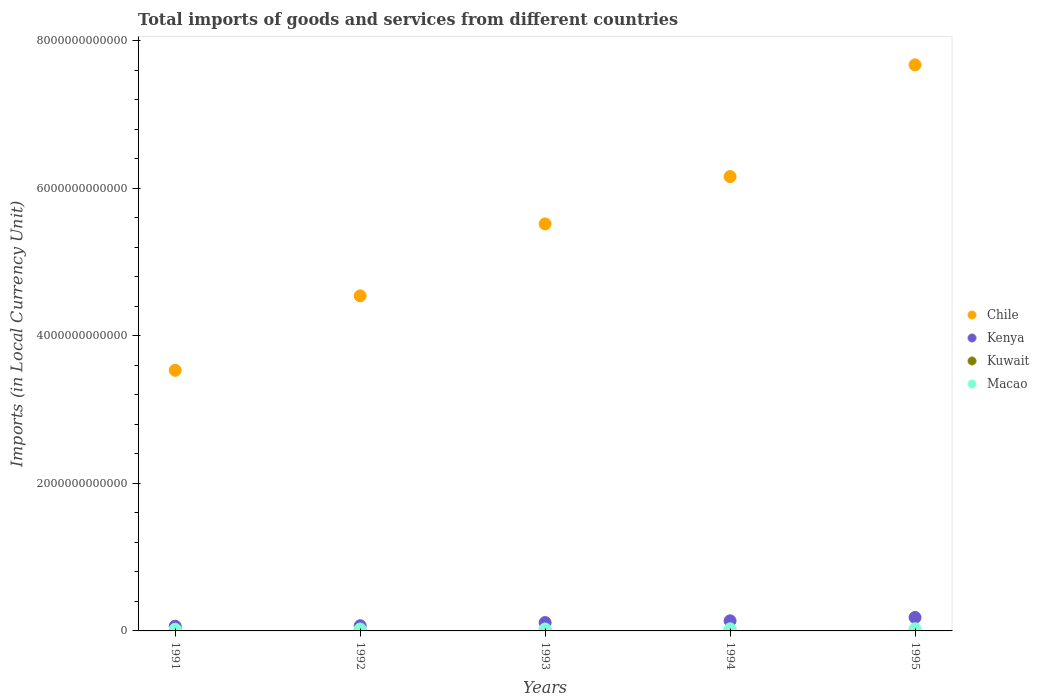How many different coloured dotlines are there?
Your answer should be very brief. 4. Is the number of dotlines equal to the number of legend labels?
Provide a succinct answer. Yes. What is the Amount of goods and services imports in Macao in 1995?
Offer a very short reply. 2.89e+1. Across all years, what is the maximum Amount of goods and services imports in Kuwait?
Your response must be concise. 3.93e+09. Across all years, what is the minimum Amount of goods and services imports in Kenya?
Offer a terse response. 6.40e+1. In which year was the Amount of goods and services imports in Macao maximum?
Give a very brief answer. 1995. In which year was the Amount of goods and services imports in Kenya minimum?
Provide a succinct answer. 1991. What is the total Amount of goods and services imports in Kuwait in the graph?
Your answer should be compact. 1.68e+1. What is the difference between the Amount of goods and services imports in Kuwait in 1993 and that in 1994?
Offer a terse response. 7.80e+07. What is the difference between the Amount of goods and services imports in Chile in 1992 and the Amount of goods and services imports in Kenya in 1994?
Your response must be concise. 4.40e+12. What is the average Amount of goods and services imports in Chile per year?
Provide a succinct answer. 5.48e+12. In the year 1992, what is the difference between the Amount of goods and services imports in Macao and Amount of goods and services imports in Kuwait?
Provide a short and direct response. 2.23e+1. In how many years, is the Amount of goods and services imports in Chile greater than 2800000000000 LCU?
Your answer should be compact. 5. What is the ratio of the Amount of goods and services imports in Chile in 1992 to that in 1995?
Provide a succinct answer. 0.59. Is the Amount of goods and services imports in Kenya in 1994 less than that in 1995?
Ensure brevity in your answer.  Yes. Is the difference between the Amount of goods and services imports in Macao in 1991 and 1993 greater than the difference between the Amount of goods and services imports in Kuwait in 1991 and 1993?
Offer a very short reply. No. What is the difference between the highest and the second highest Amount of goods and services imports in Kenya?
Ensure brevity in your answer.  4.50e+1. What is the difference between the highest and the lowest Amount of goods and services imports in Macao?
Your answer should be compact. 5.71e+09. In how many years, is the Amount of goods and services imports in Chile greater than the average Amount of goods and services imports in Chile taken over all years?
Offer a terse response. 3. Is the sum of the Amount of goods and services imports in Kuwait in 1993 and 1994 greater than the maximum Amount of goods and services imports in Macao across all years?
Make the answer very short. No. Is it the case that in every year, the sum of the Amount of goods and services imports in Kenya and Amount of goods and services imports in Chile  is greater than the sum of Amount of goods and services imports in Kuwait and Amount of goods and services imports in Macao?
Give a very brief answer. Yes. Is it the case that in every year, the sum of the Amount of goods and services imports in Kuwait and Amount of goods and services imports in Chile  is greater than the Amount of goods and services imports in Kenya?
Offer a terse response. Yes. Does the Amount of goods and services imports in Macao monotonically increase over the years?
Provide a succinct answer. Yes. Is the Amount of goods and services imports in Kenya strictly less than the Amount of goods and services imports in Macao over the years?
Offer a terse response. No. What is the difference between two consecutive major ticks on the Y-axis?
Provide a short and direct response. 2.00e+12. Are the values on the major ticks of Y-axis written in scientific E-notation?
Provide a succinct answer. No. Does the graph contain any zero values?
Give a very brief answer. No. Where does the legend appear in the graph?
Offer a very short reply. Center right. How many legend labels are there?
Offer a terse response. 4. What is the title of the graph?
Offer a terse response. Total imports of goods and services from different countries. Does "Guyana" appear as one of the legend labels in the graph?
Give a very brief answer. No. What is the label or title of the Y-axis?
Provide a succinct answer. Imports (in Local Currency Unit). What is the Imports (in Local Currency Unit) in Chile in 1991?
Make the answer very short. 3.53e+12. What is the Imports (in Local Currency Unit) in Kenya in 1991?
Keep it short and to the point. 6.40e+1. What is the Imports (in Local Currency Unit) in Kuwait in 1991?
Your response must be concise. 3.93e+09. What is the Imports (in Local Currency Unit) in Macao in 1991?
Make the answer very short. 2.32e+1. What is the Imports (in Local Currency Unit) of Chile in 1992?
Make the answer very short. 4.54e+12. What is the Imports (in Local Currency Unit) of Kenya in 1992?
Make the answer very short. 7.05e+1. What is the Imports (in Local Currency Unit) of Kuwait in 1992?
Make the answer very short. 3.16e+09. What is the Imports (in Local Currency Unit) of Macao in 1992?
Provide a short and direct response. 2.55e+1. What is the Imports (in Local Currency Unit) in Chile in 1993?
Offer a very short reply. 5.52e+12. What is the Imports (in Local Currency Unit) in Kenya in 1993?
Provide a short and direct response. 1.13e+11. What is the Imports (in Local Currency Unit) of Kuwait in 1993?
Provide a succinct answer. 3.20e+09. What is the Imports (in Local Currency Unit) in Macao in 1993?
Provide a succinct answer. 2.64e+1. What is the Imports (in Local Currency Unit) of Chile in 1994?
Your response must be concise. 6.16e+12. What is the Imports (in Local Currency Unit) in Kenya in 1994?
Provide a succinct answer. 1.37e+11. What is the Imports (in Local Currency Unit) of Kuwait in 1994?
Offer a very short reply. 3.12e+09. What is the Imports (in Local Currency Unit) in Macao in 1994?
Your response must be concise. 2.86e+1. What is the Imports (in Local Currency Unit) in Chile in 1995?
Provide a short and direct response. 7.67e+12. What is the Imports (in Local Currency Unit) of Kenya in 1995?
Keep it short and to the point. 1.82e+11. What is the Imports (in Local Currency Unit) of Kuwait in 1995?
Offer a terse response. 3.40e+09. What is the Imports (in Local Currency Unit) of Macao in 1995?
Provide a succinct answer. 2.89e+1. Across all years, what is the maximum Imports (in Local Currency Unit) in Chile?
Offer a terse response. 7.67e+12. Across all years, what is the maximum Imports (in Local Currency Unit) of Kenya?
Offer a terse response. 1.82e+11. Across all years, what is the maximum Imports (in Local Currency Unit) in Kuwait?
Provide a succinct answer. 3.93e+09. Across all years, what is the maximum Imports (in Local Currency Unit) of Macao?
Make the answer very short. 2.89e+1. Across all years, what is the minimum Imports (in Local Currency Unit) of Chile?
Make the answer very short. 3.53e+12. Across all years, what is the minimum Imports (in Local Currency Unit) of Kenya?
Keep it short and to the point. 6.40e+1. Across all years, what is the minimum Imports (in Local Currency Unit) of Kuwait?
Provide a succinct answer. 3.12e+09. Across all years, what is the minimum Imports (in Local Currency Unit) in Macao?
Offer a very short reply. 2.32e+1. What is the total Imports (in Local Currency Unit) of Chile in the graph?
Provide a succinct answer. 2.74e+13. What is the total Imports (in Local Currency Unit) in Kenya in the graph?
Provide a short and direct response. 5.67e+11. What is the total Imports (in Local Currency Unit) in Kuwait in the graph?
Your answer should be very brief. 1.68e+1. What is the total Imports (in Local Currency Unit) of Macao in the graph?
Provide a short and direct response. 1.32e+11. What is the difference between the Imports (in Local Currency Unit) in Chile in 1991 and that in 1992?
Make the answer very short. -1.01e+12. What is the difference between the Imports (in Local Currency Unit) in Kenya in 1991 and that in 1992?
Your answer should be compact. -6.50e+09. What is the difference between the Imports (in Local Currency Unit) of Kuwait in 1991 and that in 1992?
Your answer should be very brief. 7.76e+08. What is the difference between the Imports (in Local Currency Unit) of Macao in 1991 and that in 1992?
Your answer should be compact. -2.31e+09. What is the difference between the Imports (in Local Currency Unit) in Chile in 1991 and that in 1993?
Your response must be concise. -1.98e+12. What is the difference between the Imports (in Local Currency Unit) of Kenya in 1991 and that in 1993?
Keep it short and to the point. -4.92e+1. What is the difference between the Imports (in Local Currency Unit) of Kuwait in 1991 and that in 1993?
Offer a very short reply. 7.33e+08. What is the difference between the Imports (in Local Currency Unit) of Macao in 1991 and that in 1993?
Make the answer very short. -3.22e+09. What is the difference between the Imports (in Local Currency Unit) of Chile in 1991 and that in 1994?
Your response must be concise. -2.63e+12. What is the difference between the Imports (in Local Currency Unit) of Kenya in 1991 and that in 1994?
Your answer should be very brief. -7.31e+1. What is the difference between the Imports (in Local Currency Unit) of Kuwait in 1991 and that in 1994?
Provide a succinct answer. 8.11e+08. What is the difference between the Imports (in Local Currency Unit) in Macao in 1991 and that in 1994?
Provide a succinct answer. -5.41e+09. What is the difference between the Imports (in Local Currency Unit) in Chile in 1991 and that in 1995?
Ensure brevity in your answer.  -4.14e+12. What is the difference between the Imports (in Local Currency Unit) of Kenya in 1991 and that in 1995?
Offer a very short reply. -1.18e+11. What is the difference between the Imports (in Local Currency Unit) of Kuwait in 1991 and that in 1995?
Make the answer very short. 5.30e+08. What is the difference between the Imports (in Local Currency Unit) of Macao in 1991 and that in 1995?
Give a very brief answer. -5.71e+09. What is the difference between the Imports (in Local Currency Unit) in Chile in 1992 and that in 1993?
Ensure brevity in your answer.  -9.75e+11. What is the difference between the Imports (in Local Currency Unit) of Kenya in 1992 and that in 1993?
Offer a very short reply. -4.27e+1. What is the difference between the Imports (in Local Currency Unit) of Kuwait in 1992 and that in 1993?
Your answer should be very brief. -4.30e+07. What is the difference between the Imports (in Local Currency Unit) in Macao in 1992 and that in 1993?
Offer a very short reply. -9.16e+08. What is the difference between the Imports (in Local Currency Unit) of Chile in 1992 and that in 1994?
Your response must be concise. -1.62e+12. What is the difference between the Imports (in Local Currency Unit) in Kenya in 1992 and that in 1994?
Offer a terse response. -6.66e+1. What is the difference between the Imports (in Local Currency Unit) in Kuwait in 1992 and that in 1994?
Ensure brevity in your answer.  3.50e+07. What is the difference between the Imports (in Local Currency Unit) of Macao in 1992 and that in 1994?
Your answer should be compact. -3.10e+09. What is the difference between the Imports (in Local Currency Unit) of Chile in 1992 and that in 1995?
Keep it short and to the point. -3.13e+12. What is the difference between the Imports (in Local Currency Unit) of Kenya in 1992 and that in 1995?
Offer a terse response. -1.12e+11. What is the difference between the Imports (in Local Currency Unit) in Kuwait in 1992 and that in 1995?
Your response must be concise. -2.46e+08. What is the difference between the Imports (in Local Currency Unit) in Macao in 1992 and that in 1995?
Your answer should be very brief. -3.40e+09. What is the difference between the Imports (in Local Currency Unit) in Chile in 1993 and that in 1994?
Offer a terse response. -6.42e+11. What is the difference between the Imports (in Local Currency Unit) in Kenya in 1993 and that in 1994?
Offer a very short reply. -2.39e+1. What is the difference between the Imports (in Local Currency Unit) in Kuwait in 1993 and that in 1994?
Your response must be concise. 7.80e+07. What is the difference between the Imports (in Local Currency Unit) in Macao in 1993 and that in 1994?
Your answer should be compact. -2.18e+09. What is the difference between the Imports (in Local Currency Unit) of Chile in 1993 and that in 1995?
Offer a very short reply. -2.16e+12. What is the difference between the Imports (in Local Currency Unit) in Kenya in 1993 and that in 1995?
Offer a terse response. -6.89e+1. What is the difference between the Imports (in Local Currency Unit) in Kuwait in 1993 and that in 1995?
Keep it short and to the point. -2.03e+08. What is the difference between the Imports (in Local Currency Unit) of Macao in 1993 and that in 1995?
Provide a short and direct response. -2.48e+09. What is the difference between the Imports (in Local Currency Unit) in Chile in 1994 and that in 1995?
Offer a terse response. -1.51e+12. What is the difference between the Imports (in Local Currency Unit) in Kenya in 1994 and that in 1995?
Keep it short and to the point. -4.50e+1. What is the difference between the Imports (in Local Currency Unit) of Kuwait in 1994 and that in 1995?
Your answer should be very brief. -2.81e+08. What is the difference between the Imports (in Local Currency Unit) in Macao in 1994 and that in 1995?
Provide a short and direct response. -2.98e+08. What is the difference between the Imports (in Local Currency Unit) of Chile in 1991 and the Imports (in Local Currency Unit) of Kenya in 1992?
Your response must be concise. 3.46e+12. What is the difference between the Imports (in Local Currency Unit) of Chile in 1991 and the Imports (in Local Currency Unit) of Kuwait in 1992?
Your answer should be very brief. 3.53e+12. What is the difference between the Imports (in Local Currency Unit) in Chile in 1991 and the Imports (in Local Currency Unit) in Macao in 1992?
Offer a terse response. 3.51e+12. What is the difference between the Imports (in Local Currency Unit) of Kenya in 1991 and the Imports (in Local Currency Unit) of Kuwait in 1992?
Make the answer very short. 6.09e+1. What is the difference between the Imports (in Local Currency Unit) of Kenya in 1991 and the Imports (in Local Currency Unit) of Macao in 1992?
Your answer should be compact. 3.86e+1. What is the difference between the Imports (in Local Currency Unit) of Kuwait in 1991 and the Imports (in Local Currency Unit) of Macao in 1992?
Provide a short and direct response. -2.15e+1. What is the difference between the Imports (in Local Currency Unit) of Chile in 1991 and the Imports (in Local Currency Unit) of Kenya in 1993?
Offer a very short reply. 3.42e+12. What is the difference between the Imports (in Local Currency Unit) in Chile in 1991 and the Imports (in Local Currency Unit) in Kuwait in 1993?
Your response must be concise. 3.53e+12. What is the difference between the Imports (in Local Currency Unit) of Chile in 1991 and the Imports (in Local Currency Unit) of Macao in 1993?
Give a very brief answer. 3.51e+12. What is the difference between the Imports (in Local Currency Unit) in Kenya in 1991 and the Imports (in Local Currency Unit) in Kuwait in 1993?
Keep it short and to the point. 6.08e+1. What is the difference between the Imports (in Local Currency Unit) of Kenya in 1991 and the Imports (in Local Currency Unit) of Macao in 1993?
Your answer should be compact. 3.77e+1. What is the difference between the Imports (in Local Currency Unit) of Kuwait in 1991 and the Imports (in Local Currency Unit) of Macao in 1993?
Provide a short and direct response. -2.24e+1. What is the difference between the Imports (in Local Currency Unit) of Chile in 1991 and the Imports (in Local Currency Unit) of Kenya in 1994?
Ensure brevity in your answer.  3.40e+12. What is the difference between the Imports (in Local Currency Unit) in Chile in 1991 and the Imports (in Local Currency Unit) in Kuwait in 1994?
Provide a short and direct response. 3.53e+12. What is the difference between the Imports (in Local Currency Unit) of Chile in 1991 and the Imports (in Local Currency Unit) of Macao in 1994?
Keep it short and to the point. 3.50e+12. What is the difference between the Imports (in Local Currency Unit) in Kenya in 1991 and the Imports (in Local Currency Unit) in Kuwait in 1994?
Offer a terse response. 6.09e+1. What is the difference between the Imports (in Local Currency Unit) of Kenya in 1991 and the Imports (in Local Currency Unit) of Macao in 1994?
Offer a terse response. 3.55e+1. What is the difference between the Imports (in Local Currency Unit) of Kuwait in 1991 and the Imports (in Local Currency Unit) of Macao in 1994?
Make the answer very short. -2.46e+1. What is the difference between the Imports (in Local Currency Unit) in Chile in 1991 and the Imports (in Local Currency Unit) in Kenya in 1995?
Provide a succinct answer. 3.35e+12. What is the difference between the Imports (in Local Currency Unit) in Chile in 1991 and the Imports (in Local Currency Unit) in Kuwait in 1995?
Provide a succinct answer. 3.53e+12. What is the difference between the Imports (in Local Currency Unit) in Chile in 1991 and the Imports (in Local Currency Unit) in Macao in 1995?
Offer a terse response. 3.50e+12. What is the difference between the Imports (in Local Currency Unit) in Kenya in 1991 and the Imports (in Local Currency Unit) in Kuwait in 1995?
Offer a very short reply. 6.06e+1. What is the difference between the Imports (in Local Currency Unit) of Kenya in 1991 and the Imports (in Local Currency Unit) of Macao in 1995?
Give a very brief answer. 3.52e+1. What is the difference between the Imports (in Local Currency Unit) in Kuwait in 1991 and the Imports (in Local Currency Unit) in Macao in 1995?
Offer a very short reply. -2.49e+1. What is the difference between the Imports (in Local Currency Unit) of Chile in 1992 and the Imports (in Local Currency Unit) of Kenya in 1993?
Keep it short and to the point. 4.43e+12. What is the difference between the Imports (in Local Currency Unit) of Chile in 1992 and the Imports (in Local Currency Unit) of Kuwait in 1993?
Make the answer very short. 4.54e+12. What is the difference between the Imports (in Local Currency Unit) of Chile in 1992 and the Imports (in Local Currency Unit) of Macao in 1993?
Make the answer very short. 4.52e+12. What is the difference between the Imports (in Local Currency Unit) of Kenya in 1992 and the Imports (in Local Currency Unit) of Kuwait in 1993?
Your answer should be compact. 6.73e+1. What is the difference between the Imports (in Local Currency Unit) of Kenya in 1992 and the Imports (in Local Currency Unit) of Macao in 1993?
Make the answer very short. 4.42e+1. What is the difference between the Imports (in Local Currency Unit) of Kuwait in 1992 and the Imports (in Local Currency Unit) of Macao in 1993?
Give a very brief answer. -2.32e+1. What is the difference between the Imports (in Local Currency Unit) in Chile in 1992 and the Imports (in Local Currency Unit) in Kenya in 1994?
Your answer should be very brief. 4.40e+12. What is the difference between the Imports (in Local Currency Unit) of Chile in 1992 and the Imports (in Local Currency Unit) of Kuwait in 1994?
Offer a terse response. 4.54e+12. What is the difference between the Imports (in Local Currency Unit) of Chile in 1992 and the Imports (in Local Currency Unit) of Macao in 1994?
Your answer should be compact. 4.51e+12. What is the difference between the Imports (in Local Currency Unit) in Kenya in 1992 and the Imports (in Local Currency Unit) in Kuwait in 1994?
Provide a succinct answer. 6.74e+1. What is the difference between the Imports (in Local Currency Unit) of Kenya in 1992 and the Imports (in Local Currency Unit) of Macao in 1994?
Give a very brief answer. 4.20e+1. What is the difference between the Imports (in Local Currency Unit) of Kuwait in 1992 and the Imports (in Local Currency Unit) of Macao in 1994?
Your response must be concise. -2.54e+1. What is the difference between the Imports (in Local Currency Unit) in Chile in 1992 and the Imports (in Local Currency Unit) in Kenya in 1995?
Provide a short and direct response. 4.36e+12. What is the difference between the Imports (in Local Currency Unit) in Chile in 1992 and the Imports (in Local Currency Unit) in Kuwait in 1995?
Offer a very short reply. 4.54e+12. What is the difference between the Imports (in Local Currency Unit) of Chile in 1992 and the Imports (in Local Currency Unit) of Macao in 1995?
Provide a succinct answer. 4.51e+12. What is the difference between the Imports (in Local Currency Unit) of Kenya in 1992 and the Imports (in Local Currency Unit) of Kuwait in 1995?
Provide a short and direct response. 6.71e+1. What is the difference between the Imports (in Local Currency Unit) in Kenya in 1992 and the Imports (in Local Currency Unit) in Macao in 1995?
Offer a terse response. 4.17e+1. What is the difference between the Imports (in Local Currency Unit) in Kuwait in 1992 and the Imports (in Local Currency Unit) in Macao in 1995?
Provide a succinct answer. -2.57e+1. What is the difference between the Imports (in Local Currency Unit) of Chile in 1993 and the Imports (in Local Currency Unit) of Kenya in 1994?
Your response must be concise. 5.38e+12. What is the difference between the Imports (in Local Currency Unit) in Chile in 1993 and the Imports (in Local Currency Unit) in Kuwait in 1994?
Ensure brevity in your answer.  5.51e+12. What is the difference between the Imports (in Local Currency Unit) of Chile in 1993 and the Imports (in Local Currency Unit) of Macao in 1994?
Make the answer very short. 5.49e+12. What is the difference between the Imports (in Local Currency Unit) of Kenya in 1993 and the Imports (in Local Currency Unit) of Kuwait in 1994?
Offer a very short reply. 1.10e+11. What is the difference between the Imports (in Local Currency Unit) in Kenya in 1993 and the Imports (in Local Currency Unit) in Macao in 1994?
Your response must be concise. 8.47e+1. What is the difference between the Imports (in Local Currency Unit) of Kuwait in 1993 and the Imports (in Local Currency Unit) of Macao in 1994?
Your answer should be compact. -2.54e+1. What is the difference between the Imports (in Local Currency Unit) of Chile in 1993 and the Imports (in Local Currency Unit) of Kenya in 1995?
Offer a terse response. 5.33e+12. What is the difference between the Imports (in Local Currency Unit) of Chile in 1993 and the Imports (in Local Currency Unit) of Kuwait in 1995?
Provide a succinct answer. 5.51e+12. What is the difference between the Imports (in Local Currency Unit) of Chile in 1993 and the Imports (in Local Currency Unit) of Macao in 1995?
Make the answer very short. 5.49e+12. What is the difference between the Imports (in Local Currency Unit) of Kenya in 1993 and the Imports (in Local Currency Unit) of Kuwait in 1995?
Your answer should be compact. 1.10e+11. What is the difference between the Imports (in Local Currency Unit) in Kenya in 1993 and the Imports (in Local Currency Unit) in Macao in 1995?
Provide a succinct answer. 8.44e+1. What is the difference between the Imports (in Local Currency Unit) of Kuwait in 1993 and the Imports (in Local Currency Unit) of Macao in 1995?
Keep it short and to the point. -2.57e+1. What is the difference between the Imports (in Local Currency Unit) of Chile in 1994 and the Imports (in Local Currency Unit) of Kenya in 1995?
Give a very brief answer. 5.98e+12. What is the difference between the Imports (in Local Currency Unit) in Chile in 1994 and the Imports (in Local Currency Unit) in Kuwait in 1995?
Your answer should be compact. 6.16e+12. What is the difference between the Imports (in Local Currency Unit) of Chile in 1994 and the Imports (in Local Currency Unit) of Macao in 1995?
Make the answer very short. 6.13e+12. What is the difference between the Imports (in Local Currency Unit) of Kenya in 1994 and the Imports (in Local Currency Unit) of Kuwait in 1995?
Provide a short and direct response. 1.34e+11. What is the difference between the Imports (in Local Currency Unit) in Kenya in 1994 and the Imports (in Local Currency Unit) in Macao in 1995?
Ensure brevity in your answer.  1.08e+11. What is the difference between the Imports (in Local Currency Unit) of Kuwait in 1994 and the Imports (in Local Currency Unit) of Macao in 1995?
Offer a terse response. -2.57e+1. What is the average Imports (in Local Currency Unit) in Chile per year?
Make the answer very short. 5.48e+12. What is the average Imports (in Local Currency Unit) in Kenya per year?
Provide a short and direct response. 1.13e+11. What is the average Imports (in Local Currency Unit) in Kuwait per year?
Your answer should be very brief. 3.36e+09. What is the average Imports (in Local Currency Unit) of Macao per year?
Provide a short and direct response. 2.65e+1. In the year 1991, what is the difference between the Imports (in Local Currency Unit) of Chile and Imports (in Local Currency Unit) of Kenya?
Make the answer very short. 3.47e+12. In the year 1991, what is the difference between the Imports (in Local Currency Unit) of Chile and Imports (in Local Currency Unit) of Kuwait?
Your response must be concise. 3.53e+12. In the year 1991, what is the difference between the Imports (in Local Currency Unit) of Chile and Imports (in Local Currency Unit) of Macao?
Provide a short and direct response. 3.51e+12. In the year 1991, what is the difference between the Imports (in Local Currency Unit) of Kenya and Imports (in Local Currency Unit) of Kuwait?
Your response must be concise. 6.01e+1. In the year 1991, what is the difference between the Imports (in Local Currency Unit) in Kenya and Imports (in Local Currency Unit) in Macao?
Your answer should be very brief. 4.09e+1. In the year 1991, what is the difference between the Imports (in Local Currency Unit) in Kuwait and Imports (in Local Currency Unit) in Macao?
Give a very brief answer. -1.92e+1. In the year 1992, what is the difference between the Imports (in Local Currency Unit) of Chile and Imports (in Local Currency Unit) of Kenya?
Provide a short and direct response. 4.47e+12. In the year 1992, what is the difference between the Imports (in Local Currency Unit) of Chile and Imports (in Local Currency Unit) of Kuwait?
Give a very brief answer. 4.54e+12. In the year 1992, what is the difference between the Imports (in Local Currency Unit) in Chile and Imports (in Local Currency Unit) in Macao?
Make the answer very short. 4.52e+12. In the year 1992, what is the difference between the Imports (in Local Currency Unit) of Kenya and Imports (in Local Currency Unit) of Kuwait?
Offer a terse response. 6.74e+1. In the year 1992, what is the difference between the Imports (in Local Currency Unit) of Kenya and Imports (in Local Currency Unit) of Macao?
Provide a short and direct response. 4.51e+1. In the year 1992, what is the difference between the Imports (in Local Currency Unit) of Kuwait and Imports (in Local Currency Unit) of Macao?
Provide a short and direct response. -2.23e+1. In the year 1993, what is the difference between the Imports (in Local Currency Unit) of Chile and Imports (in Local Currency Unit) of Kenya?
Give a very brief answer. 5.40e+12. In the year 1993, what is the difference between the Imports (in Local Currency Unit) of Chile and Imports (in Local Currency Unit) of Kuwait?
Keep it short and to the point. 5.51e+12. In the year 1993, what is the difference between the Imports (in Local Currency Unit) in Chile and Imports (in Local Currency Unit) in Macao?
Provide a succinct answer. 5.49e+12. In the year 1993, what is the difference between the Imports (in Local Currency Unit) of Kenya and Imports (in Local Currency Unit) of Kuwait?
Provide a succinct answer. 1.10e+11. In the year 1993, what is the difference between the Imports (in Local Currency Unit) in Kenya and Imports (in Local Currency Unit) in Macao?
Provide a succinct answer. 8.69e+1. In the year 1993, what is the difference between the Imports (in Local Currency Unit) of Kuwait and Imports (in Local Currency Unit) of Macao?
Your response must be concise. -2.32e+1. In the year 1994, what is the difference between the Imports (in Local Currency Unit) in Chile and Imports (in Local Currency Unit) in Kenya?
Provide a succinct answer. 6.02e+12. In the year 1994, what is the difference between the Imports (in Local Currency Unit) in Chile and Imports (in Local Currency Unit) in Kuwait?
Offer a very short reply. 6.16e+12. In the year 1994, what is the difference between the Imports (in Local Currency Unit) in Chile and Imports (in Local Currency Unit) in Macao?
Offer a very short reply. 6.13e+12. In the year 1994, what is the difference between the Imports (in Local Currency Unit) in Kenya and Imports (in Local Currency Unit) in Kuwait?
Keep it short and to the point. 1.34e+11. In the year 1994, what is the difference between the Imports (in Local Currency Unit) in Kenya and Imports (in Local Currency Unit) in Macao?
Your answer should be compact. 1.09e+11. In the year 1994, what is the difference between the Imports (in Local Currency Unit) in Kuwait and Imports (in Local Currency Unit) in Macao?
Keep it short and to the point. -2.54e+1. In the year 1995, what is the difference between the Imports (in Local Currency Unit) of Chile and Imports (in Local Currency Unit) of Kenya?
Your answer should be very brief. 7.49e+12. In the year 1995, what is the difference between the Imports (in Local Currency Unit) of Chile and Imports (in Local Currency Unit) of Kuwait?
Your answer should be very brief. 7.67e+12. In the year 1995, what is the difference between the Imports (in Local Currency Unit) of Chile and Imports (in Local Currency Unit) of Macao?
Provide a short and direct response. 7.64e+12. In the year 1995, what is the difference between the Imports (in Local Currency Unit) in Kenya and Imports (in Local Currency Unit) in Kuwait?
Offer a very short reply. 1.79e+11. In the year 1995, what is the difference between the Imports (in Local Currency Unit) in Kenya and Imports (in Local Currency Unit) in Macao?
Your answer should be very brief. 1.53e+11. In the year 1995, what is the difference between the Imports (in Local Currency Unit) in Kuwait and Imports (in Local Currency Unit) in Macao?
Ensure brevity in your answer.  -2.55e+1. What is the ratio of the Imports (in Local Currency Unit) in Kenya in 1991 to that in 1992?
Your answer should be very brief. 0.91. What is the ratio of the Imports (in Local Currency Unit) in Kuwait in 1991 to that in 1992?
Give a very brief answer. 1.25. What is the ratio of the Imports (in Local Currency Unit) in Macao in 1991 to that in 1992?
Provide a short and direct response. 0.91. What is the ratio of the Imports (in Local Currency Unit) in Chile in 1991 to that in 1993?
Provide a succinct answer. 0.64. What is the ratio of the Imports (in Local Currency Unit) of Kenya in 1991 to that in 1993?
Keep it short and to the point. 0.57. What is the ratio of the Imports (in Local Currency Unit) of Kuwait in 1991 to that in 1993?
Offer a terse response. 1.23. What is the ratio of the Imports (in Local Currency Unit) of Macao in 1991 to that in 1993?
Make the answer very short. 0.88. What is the ratio of the Imports (in Local Currency Unit) of Chile in 1991 to that in 1994?
Your answer should be very brief. 0.57. What is the ratio of the Imports (in Local Currency Unit) of Kenya in 1991 to that in 1994?
Your response must be concise. 0.47. What is the ratio of the Imports (in Local Currency Unit) of Kuwait in 1991 to that in 1994?
Your answer should be very brief. 1.26. What is the ratio of the Imports (in Local Currency Unit) of Macao in 1991 to that in 1994?
Make the answer very short. 0.81. What is the ratio of the Imports (in Local Currency Unit) in Chile in 1991 to that in 1995?
Your answer should be compact. 0.46. What is the ratio of the Imports (in Local Currency Unit) in Kenya in 1991 to that in 1995?
Your response must be concise. 0.35. What is the ratio of the Imports (in Local Currency Unit) of Kuwait in 1991 to that in 1995?
Provide a short and direct response. 1.16. What is the ratio of the Imports (in Local Currency Unit) in Macao in 1991 to that in 1995?
Provide a succinct answer. 0.8. What is the ratio of the Imports (in Local Currency Unit) of Chile in 1992 to that in 1993?
Keep it short and to the point. 0.82. What is the ratio of the Imports (in Local Currency Unit) of Kenya in 1992 to that in 1993?
Provide a short and direct response. 0.62. What is the ratio of the Imports (in Local Currency Unit) of Kuwait in 1992 to that in 1993?
Offer a very short reply. 0.99. What is the ratio of the Imports (in Local Currency Unit) in Macao in 1992 to that in 1993?
Your answer should be very brief. 0.97. What is the ratio of the Imports (in Local Currency Unit) in Chile in 1992 to that in 1994?
Keep it short and to the point. 0.74. What is the ratio of the Imports (in Local Currency Unit) of Kenya in 1992 to that in 1994?
Your response must be concise. 0.51. What is the ratio of the Imports (in Local Currency Unit) of Kuwait in 1992 to that in 1994?
Offer a terse response. 1.01. What is the ratio of the Imports (in Local Currency Unit) of Macao in 1992 to that in 1994?
Provide a succinct answer. 0.89. What is the ratio of the Imports (in Local Currency Unit) in Chile in 1992 to that in 1995?
Offer a terse response. 0.59. What is the ratio of the Imports (in Local Currency Unit) of Kenya in 1992 to that in 1995?
Make the answer very short. 0.39. What is the ratio of the Imports (in Local Currency Unit) of Kuwait in 1992 to that in 1995?
Give a very brief answer. 0.93. What is the ratio of the Imports (in Local Currency Unit) in Macao in 1992 to that in 1995?
Your response must be concise. 0.88. What is the ratio of the Imports (in Local Currency Unit) in Chile in 1993 to that in 1994?
Make the answer very short. 0.9. What is the ratio of the Imports (in Local Currency Unit) in Kenya in 1993 to that in 1994?
Give a very brief answer. 0.83. What is the ratio of the Imports (in Local Currency Unit) in Macao in 1993 to that in 1994?
Offer a very short reply. 0.92. What is the ratio of the Imports (in Local Currency Unit) in Chile in 1993 to that in 1995?
Keep it short and to the point. 0.72. What is the ratio of the Imports (in Local Currency Unit) of Kenya in 1993 to that in 1995?
Provide a succinct answer. 0.62. What is the ratio of the Imports (in Local Currency Unit) in Kuwait in 1993 to that in 1995?
Provide a short and direct response. 0.94. What is the ratio of the Imports (in Local Currency Unit) of Macao in 1993 to that in 1995?
Your answer should be very brief. 0.91. What is the ratio of the Imports (in Local Currency Unit) in Chile in 1994 to that in 1995?
Offer a terse response. 0.8. What is the ratio of the Imports (in Local Currency Unit) in Kenya in 1994 to that in 1995?
Keep it short and to the point. 0.75. What is the ratio of the Imports (in Local Currency Unit) in Kuwait in 1994 to that in 1995?
Your answer should be very brief. 0.92. What is the difference between the highest and the second highest Imports (in Local Currency Unit) in Chile?
Ensure brevity in your answer.  1.51e+12. What is the difference between the highest and the second highest Imports (in Local Currency Unit) in Kenya?
Provide a succinct answer. 4.50e+1. What is the difference between the highest and the second highest Imports (in Local Currency Unit) of Kuwait?
Your response must be concise. 5.30e+08. What is the difference between the highest and the second highest Imports (in Local Currency Unit) in Macao?
Offer a very short reply. 2.98e+08. What is the difference between the highest and the lowest Imports (in Local Currency Unit) in Chile?
Make the answer very short. 4.14e+12. What is the difference between the highest and the lowest Imports (in Local Currency Unit) in Kenya?
Give a very brief answer. 1.18e+11. What is the difference between the highest and the lowest Imports (in Local Currency Unit) of Kuwait?
Offer a very short reply. 8.11e+08. What is the difference between the highest and the lowest Imports (in Local Currency Unit) of Macao?
Your answer should be very brief. 5.71e+09. 